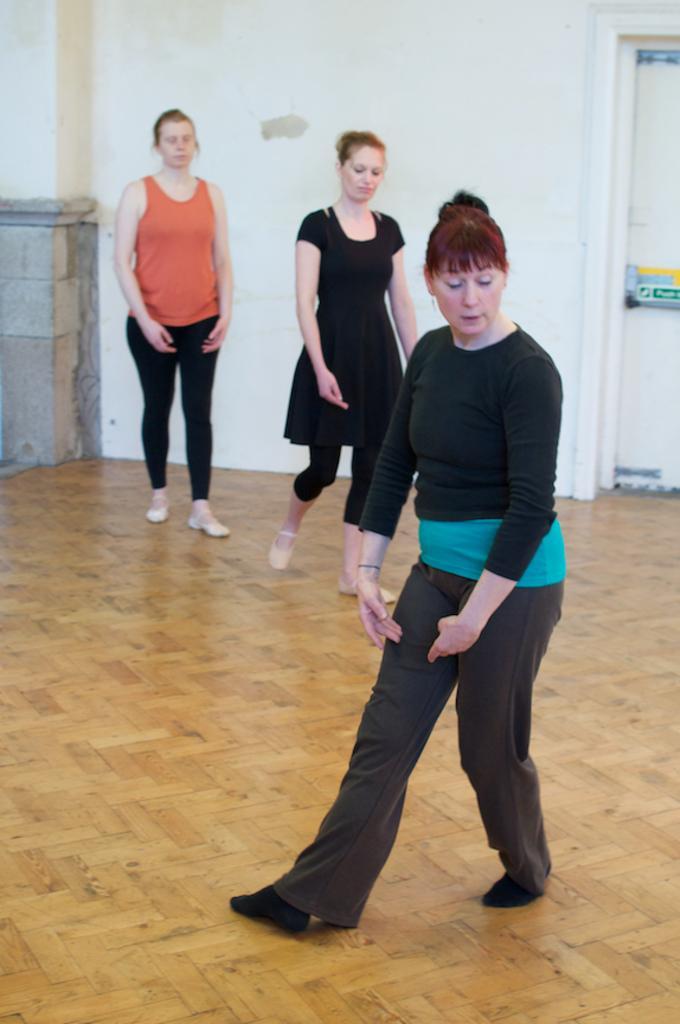In one or two sentences, can you explain what this image depicts? In this image we can see three women standing on the ground. One woman is wearing a black dress. one woman is wearing an orange dress. In the background, we can see the door. 